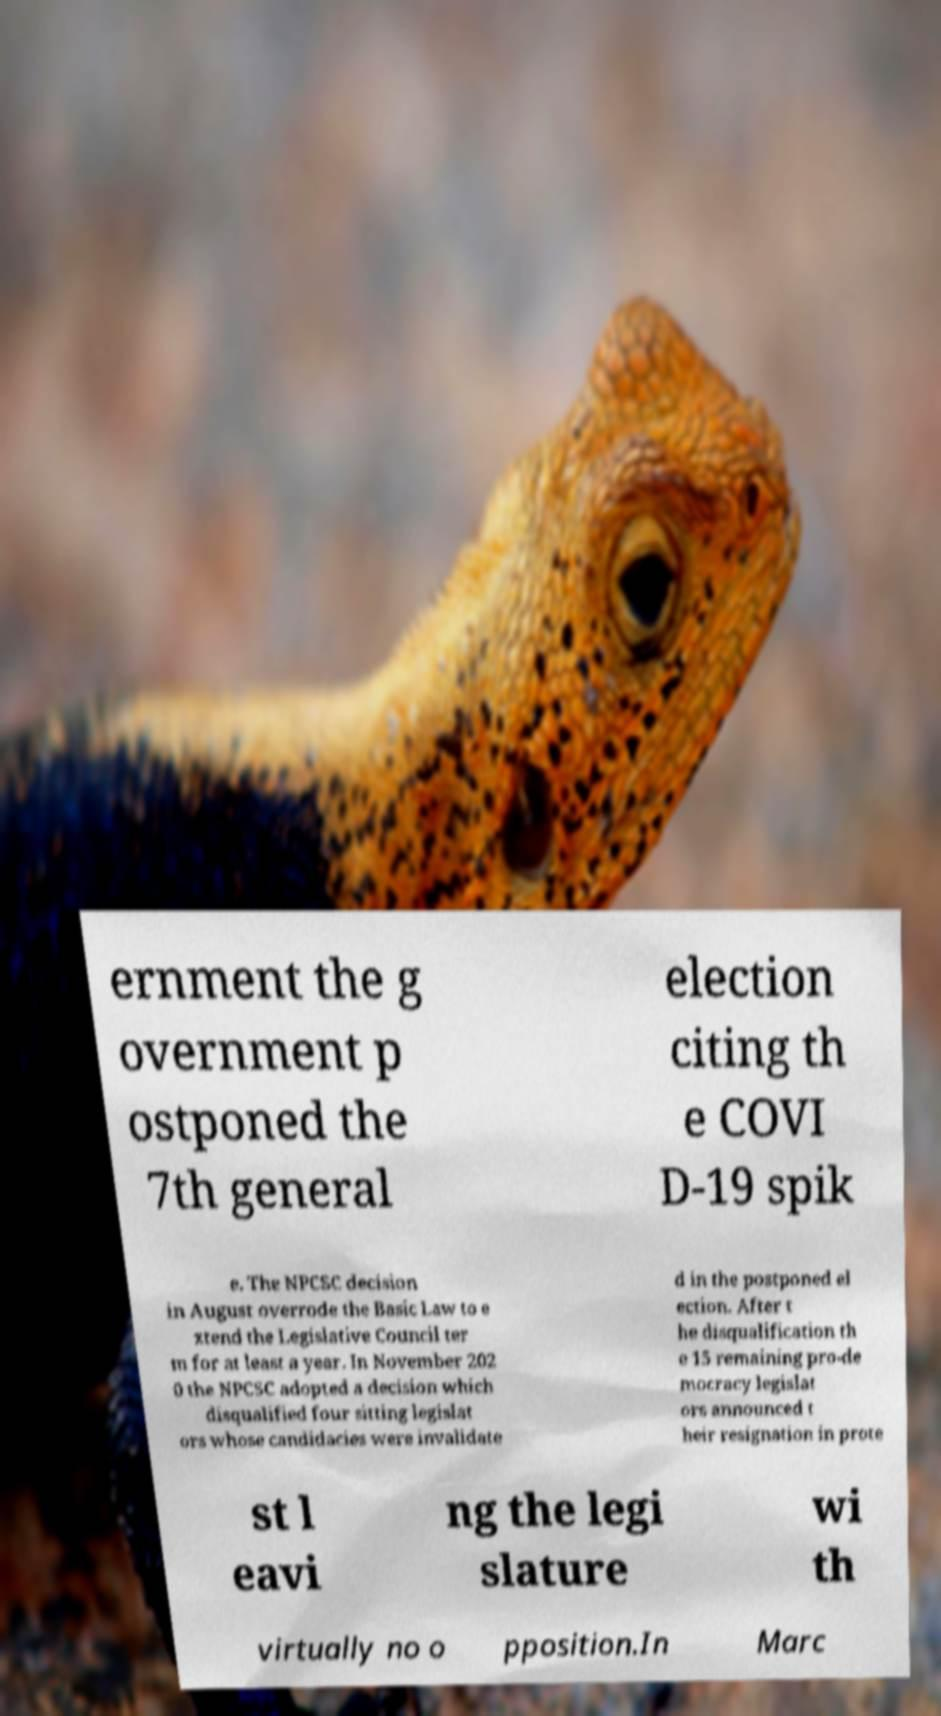Can you accurately transcribe the text from the provided image for me? ernment the g overnment p ostponed the 7th general election citing th e COVI D-19 spik e. The NPCSC decision in August overrode the Basic Law to e xtend the Legislative Council ter m for at least a year. In November 202 0 the NPCSC adopted a decision which disqualified four sitting legislat ors whose candidacies were invalidate d in the postponed el ection. After t he disqualification th e 15 remaining pro-de mocracy legislat ors announced t heir resignation in prote st l eavi ng the legi slature wi th virtually no o pposition.In Marc 